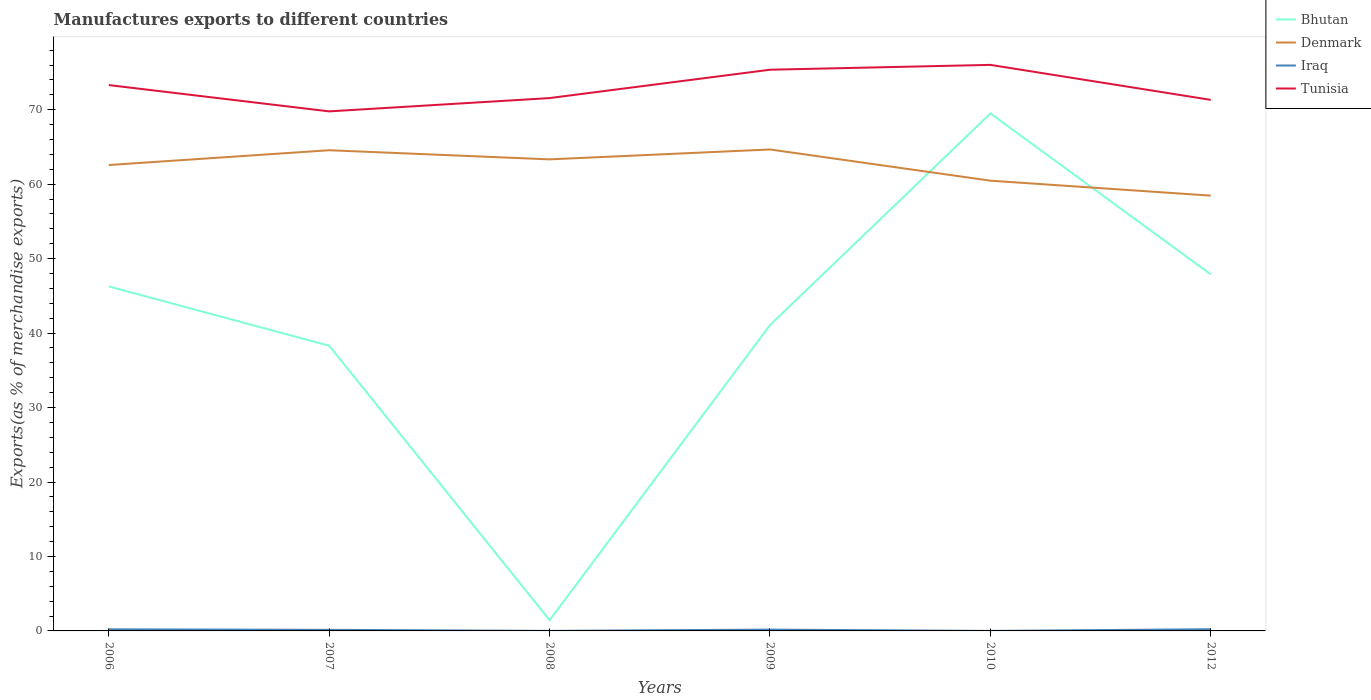How many different coloured lines are there?
Your response must be concise. 4. Across all years, what is the maximum percentage of exports to different countries in Iraq?
Your response must be concise. 1.17829425894477e-5. In which year was the percentage of exports to different countries in Tunisia maximum?
Provide a succinct answer. 2007. What is the total percentage of exports to different countries in Bhutan in the graph?
Provide a short and direct response. 5.19. What is the difference between the highest and the second highest percentage of exports to different countries in Bhutan?
Give a very brief answer. 68.06. Is the percentage of exports to different countries in Tunisia strictly greater than the percentage of exports to different countries in Iraq over the years?
Keep it short and to the point. No. How many lines are there?
Provide a short and direct response. 4. How many years are there in the graph?
Offer a terse response. 6. What is the difference between two consecutive major ticks on the Y-axis?
Your answer should be compact. 10. Are the values on the major ticks of Y-axis written in scientific E-notation?
Your answer should be compact. No. Does the graph contain any zero values?
Your response must be concise. No. Where does the legend appear in the graph?
Provide a short and direct response. Top right. How many legend labels are there?
Keep it short and to the point. 4. How are the legend labels stacked?
Your answer should be very brief. Vertical. What is the title of the graph?
Keep it short and to the point. Manufactures exports to different countries. What is the label or title of the Y-axis?
Offer a very short reply. Exports(as % of merchandise exports). What is the Exports(as % of merchandise exports) of Bhutan in 2006?
Your answer should be very brief. 46.27. What is the Exports(as % of merchandise exports) in Denmark in 2006?
Offer a terse response. 62.58. What is the Exports(as % of merchandise exports) of Iraq in 2006?
Make the answer very short. 0.22. What is the Exports(as % of merchandise exports) in Tunisia in 2006?
Your answer should be very brief. 73.31. What is the Exports(as % of merchandise exports) of Bhutan in 2007?
Your answer should be very brief. 38.3. What is the Exports(as % of merchandise exports) of Denmark in 2007?
Your response must be concise. 64.56. What is the Exports(as % of merchandise exports) of Iraq in 2007?
Keep it short and to the point. 0.14. What is the Exports(as % of merchandise exports) in Tunisia in 2007?
Your answer should be compact. 69.78. What is the Exports(as % of merchandise exports) in Bhutan in 2008?
Provide a short and direct response. 1.44. What is the Exports(as % of merchandise exports) of Denmark in 2008?
Offer a terse response. 63.34. What is the Exports(as % of merchandise exports) of Iraq in 2008?
Your answer should be compact. 0.01. What is the Exports(as % of merchandise exports) in Tunisia in 2008?
Make the answer very short. 71.57. What is the Exports(as % of merchandise exports) of Bhutan in 2009?
Offer a very short reply. 41.08. What is the Exports(as % of merchandise exports) of Denmark in 2009?
Give a very brief answer. 64.66. What is the Exports(as % of merchandise exports) in Iraq in 2009?
Provide a short and direct response. 0.18. What is the Exports(as % of merchandise exports) in Tunisia in 2009?
Make the answer very short. 75.37. What is the Exports(as % of merchandise exports) in Bhutan in 2010?
Offer a very short reply. 69.5. What is the Exports(as % of merchandise exports) in Denmark in 2010?
Make the answer very short. 60.47. What is the Exports(as % of merchandise exports) of Iraq in 2010?
Give a very brief answer. 1.17829425894477e-5. What is the Exports(as % of merchandise exports) in Tunisia in 2010?
Your response must be concise. 76.03. What is the Exports(as % of merchandise exports) in Bhutan in 2012?
Ensure brevity in your answer.  47.88. What is the Exports(as % of merchandise exports) of Denmark in 2012?
Your answer should be very brief. 58.46. What is the Exports(as % of merchandise exports) of Iraq in 2012?
Your answer should be compact. 0.23. What is the Exports(as % of merchandise exports) in Tunisia in 2012?
Offer a terse response. 71.32. Across all years, what is the maximum Exports(as % of merchandise exports) of Bhutan?
Make the answer very short. 69.5. Across all years, what is the maximum Exports(as % of merchandise exports) of Denmark?
Your answer should be compact. 64.66. Across all years, what is the maximum Exports(as % of merchandise exports) of Iraq?
Your response must be concise. 0.23. Across all years, what is the maximum Exports(as % of merchandise exports) in Tunisia?
Provide a short and direct response. 76.03. Across all years, what is the minimum Exports(as % of merchandise exports) of Bhutan?
Your response must be concise. 1.44. Across all years, what is the minimum Exports(as % of merchandise exports) of Denmark?
Offer a terse response. 58.46. Across all years, what is the minimum Exports(as % of merchandise exports) of Iraq?
Your answer should be very brief. 1.17829425894477e-5. Across all years, what is the minimum Exports(as % of merchandise exports) of Tunisia?
Your answer should be very brief. 69.78. What is the total Exports(as % of merchandise exports) of Bhutan in the graph?
Offer a very short reply. 244.47. What is the total Exports(as % of merchandise exports) in Denmark in the graph?
Your answer should be compact. 374.07. What is the total Exports(as % of merchandise exports) of Iraq in the graph?
Ensure brevity in your answer.  0.77. What is the total Exports(as % of merchandise exports) of Tunisia in the graph?
Your response must be concise. 437.38. What is the difference between the Exports(as % of merchandise exports) in Bhutan in 2006 and that in 2007?
Your response must be concise. 7.96. What is the difference between the Exports(as % of merchandise exports) of Denmark in 2006 and that in 2007?
Offer a very short reply. -1.99. What is the difference between the Exports(as % of merchandise exports) in Iraq in 2006 and that in 2007?
Make the answer very short. 0.07. What is the difference between the Exports(as % of merchandise exports) of Tunisia in 2006 and that in 2007?
Make the answer very short. 3.53. What is the difference between the Exports(as % of merchandise exports) in Bhutan in 2006 and that in 2008?
Your response must be concise. 44.83. What is the difference between the Exports(as % of merchandise exports) in Denmark in 2006 and that in 2008?
Offer a terse response. -0.76. What is the difference between the Exports(as % of merchandise exports) in Iraq in 2006 and that in 2008?
Give a very brief answer. 0.21. What is the difference between the Exports(as % of merchandise exports) of Tunisia in 2006 and that in 2008?
Make the answer very short. 1.75. What is the difference between the Exports(as % of merchandise exports) in Bhutan in 2006 and that in 2009?
Provide a short and direct response. 5.19. What is the difference between the Exports(as % of merchandise exports) of Denmark in 2006 and that in 2009?
Offer a terse response. -2.09. What is the difference between the Exports(as % of merchandise exports) in Iraq in 2006 and that in 2009?
Offer a very short reply. 0.04. What is the difference between the Exports(as % of merchandise exports) of Tunisia in 2006 and that in 2009?
Provide a short and direct response. -2.06. What is the difference between the Exports(as % of merchandise exports) of Bhutan in 2006 and that in 2010?
Make the answer very short. -23.24. What is the difference between the Exports(as % of merchandise exports) in Denmark in 2006 and that in 2010?
Provide a short and direct response. 2.1. What is the difference between the Exports(as % of merchandise exports) of Iraq in 2006 and that in 2010?
Offer a terse response. 0.22. What is the difference between the Exports(as % of merchandise exports) of Tunisia in 2006 and that in 2010?
Your answer should be compact. -2.71. What is the difference between the Exports(as % of merchandise exports) of Bhutan in 2006 and that in 2012?
Ensure brevity in your answer.  -1.61. What is the difference between the Exports(as % of merchandise exports) of Denmark in 2006 and that in 2012?
Ensure brevity in your answer.  4.11. What is the difference between the Exports(as % of merchandise exports) of Iraq in 2006 and that in 2012?
Offer a very short reply. -0.01. What is the difference between the Exports(as % of merchandise exports) in Tunisia in 2006 and that in 2012?
Provide a short and direct response. 1.99. What is the difference between the Exports(as % of merchandise exports) of Bhutan in 2007 and that in 2008?
Your answer should be compact. 36.86. What is the difference between the Exports(as % of merchandise exports) of Denmark in 2007 and that in 2008?
Give a very brief answer. 1.23. What is the difference between the Exports(as % of merchandise exports) of Iraq in 2007 and that in 2008?
Ensure brevity in your answer.  0.14. What is the difference between the Exports(as % of merchandise exports) in Tunisia in 2007 and that in 2008?
Give a very brief answer. -1.79. What is the difference between the Exports(as % of merchandise exports) in Bhutan in 2007 and that in 2009?
Provide a short and direct response. -2.77. What is the difference between the Exports(as % of merchandise exports) of Denmark in 2007 and that in 2009?
Offer a terse response. -0.1. What is the difference between the Exports(as % of merchandise exports) of Iraq in 2007 and that in 2009?
Keep it short and to the point. -0.03. What is the difference between the Exports(as % of merchandise exports) in Tunisia in 2007 and that in 2009?
Ensure brevity in your answer.  -5.59. What is the difference between the Exports(as % of merchandise exports) in Bhutan in 2007 and that in 2010?
Your answer should be compact. -31.2. What is the difference between the Exports(as % of merchandise exports) of Denmark in 2007 and that in 2010?
Your response must be concise. 4.09. What is the difference between the Exports(as % of merchandise exports) of Iraq in 2007 and that in 2010?
Your response must be concise. 0.14. What is the difference between the Exports(as % of merchandise exports) in Tunisia in 2007 and that in 2010?
Provide a succinct answer. -6.25. What is the difference between the Exports(as % of merchandise exports) in Bhutan in 2007 and that in 2012?
Make the answer very short. -9.57. What is the difference between the Exports(as % of merchandise exports) of Denmark in 2007 and that in 2012?
Your answer should be very brief. 6.1. What is the difference between the Exports(as % of merchandise exports) of Iraq in 2007 and that in 2012?
Your answer should be compact. -0.08. What is the difference between the Exports(as % of merchandise exports) of Tunisia in 2007 and that in 2012?
Make the answer very short. -1.54. What is the difference between the Exports(as % of merchandise exports) of Bhutan in 2008 and that in 2009?
Provide a short and direct response. -39.64. What is the difference between the Exports(as % of merchandise exports) in Denmark in 2008 and that in 2009?
Give a very brief answer. -1.33. What is the difference between the Exports(as % of merchandise exports) of Iraq in 2008 and that in 2009?
Offer a very short reply. -0.17. What is the difference between the Exports(as % of merchandise exports) in Tunisia in 2008 and that in 2009?
Ensure brevity in your answer.  -3.81. What is the difference between the Exports(as % of merchandise exports) in Bhutan in 2008 and that in 2010?
Provide a succinct answer. -68.06. What is the difference between the Exports(as % of merchandise exports) in Denmark in 2008 and that in 2010?
Keep it short and to the point. 2.86. What is the difference between the Exports(as % of merchandise exports) of Iraq in 2008 and that in 2010?
Provide a short and direct response. 0.01. What is the difference between the Exports(as % of merchandise exports) of Tunisia in 2008 and that in 2010?
Your answer should be very brief. -4.46. What is the difference between the Exports(as % of merchandise exports) of Bhutan in 2008 and that in 2012?
Provide a succinct answer. -46.44. What is the difference between the Exports(as % of merchandise exports) in Denmark in 2008 and that in 2012?
Make the answer very short. 4.87. What is the difference between the Exports(as % of merchandise exports) in Iraq in 2008 and that in 2012?
Make the answer very short. -0.22. What is the difference between the Exports(as % of merchandise exports) of Tunisia in 2008 and that in 2012?
Offer a very short reply. 0.24. What is the difference between the Exports(as % of merchandise exports) in Bhutan in 2009 and that in 2010?
Provide a succinct answer. -28.43. What is the difference between the Exports(as % of merchandise exports) of Denmark in 2009 and that in 2010?
Offer a very short reply. 4.19. What is the difference between the Exports(as % of merchandise exports) in Iraq in 2009 and that in 2010?
Ensure brevity in your answer.  0.18. What is the difference between the Exports(as % of merchandise exports) of Tunisia in 2009 and that in 2010?
Provide a succinct answer. -0.65. What is the difference between the Exports(as % of merchandise exports) in Bhutan in 2009 and that in 2012?
Provide a short and direct response. -6.8. What is the difference between the Exports(as % of merchandise exports) of Denmark in 2009 and that in 2012?
Provide a short and direct response. 6.2. What is the difference between the Exports(as % of merchandise exports) of Iraq in 2009 and that in 2012?
Your answer should be very brief. -0.05. What is the difference between the Exports(as % of merchandise exports) in Tunisia in 2009 and that in 2012?
Your response must be concise. 4.05. What is the difference between the Exports(as % of merchandise exports) of Bhutan in 2010 and that in 2012?
Offer a very short reply. 21.63. What is the difference between the Exports(as % of merchandise exports) of Denmark in 2010 and that in 2012?
Give a very brief answer. 2.01. What is the difference between the Exports(as % of merchandise exports) in Iraq in 2010 and that in 2012?
Your response must be concise. -0.23. What is the difference between the Exports(as % of merchandise exports) of Tunisia in 2010 and that in 2012?
Your answer should be very brief. 4.7. What is the difference between the Exports(as % of merchandise exports) in Bhutan in 2006 and the Exports(as % of merchandise exports) in Denmark in 2007?
Provide a short and direct response. -18.29. What is the difference between the Exports(as % of merchandise exports) in Bhutan in 2006 and the Exports(as % of merchandise exports) in Iraq in 2007?
Your answer should be very brief. 46.12. What is the difference between the Exports(as % of merchandise exports) of Bhutan in 2006 and the Exports(as % of merchandise exports) of Tunisia in 2007?
Your answer should be very brief. -23.51. What is the difference between the Exports(as % of merchandise exports) of Denmark in 2006 and the Exports(as % of merchandise exports) of Iraq in 2007?
Keep it short and to the point. 62.43. What is the difference between the Exports(as % of merchandise exports) in Denmark in 2006 and the Exports(as % of merchandise exports) in Tunisia in 2007?
Offer a very short reply. -7.2. What is the difference between the Exports(as % of merchandise exports) of Iraq in 2006 and the Exports(as % of merchandise exports) of Tunisia in 2007?
Your answer should be very brief. -69.56. What is the difference between the Exports(as % of merchandise exports) of Bhutan in 2006 and the Exports(as % of merchandise exports) of Denmark in 2008?
Offer a very short reply. -17.07. What is the difference between the Exports(as % of merchandise exports) in Bhutan in 2006 and the Exports(as % of merchandise exports) in Iraq in 2008?
Your answer should be compact. 46.26. What is the difference between the Exports(as % of merchandise exports) of Bhutan in 2006 and the Exports(as % of merchandise exports) of Tunisia in 2008?
Provide a succinct answer. -25.3. What is the difference between the Exports(as % of merchandise exports) in Denmark in 2006 and the Exports(as % of merchandise exports) in Iraq in 2008?
Your response must be concise. 62.57. What is the difference between the Exports(as % of merchandise exports) in Denmark in 2006 and the Exports(as % of merchandise exports) in Tunisia in 2008?
Your response must be concise. -8.99. What is the difference between the Exports(as % of merchandise exports) in Iraq in 2006 and the Exports(as % of merchandise exports) in Tunisia in 2008?
Make the answer very short. -71.35. What is the difference between the Exports(as % of merchandise exports) in Bhutan in 2006 and the Exports(as % of merchandise exports) in Denmark in 2009?
Your answer should be very brief. -18.4. What is the difference between the Exports(as % of merchandise exports) of Bhutan in 2006 and the Exports(as % of merchandise exports) of Iraq in 2009?
Keep it short and to the point. 46.09. What is the difference between the Exports(as % of merchandise exports) of Bhutan in 2006 and the Exports(as % of merchandise exports) of Tunisia in 2009?
Your answer should be compact. -29.11. What is the difference between the Exports(as % of merchandise exports) in Denmark in 2006 and the Exports(as % of merchandise exports) in Iraq in 2009?
Provide a succinct answer. 62.4. What is the difference between the Exports(as % of merchandise exports) of Denmark in 2006 and the Exports(as % of merchandise exports) of Tunisia in 2009?
Keep it short and to the point. -12.8. What is the difference between the Exports(as % of merchandise exports) in Iraq in 2006 and the Exports(as % of merchandise exports) in Tunisia in 2009?
Provide a succinct answer. -75.16. What is the difference between the Exports(as % of merchandise exports) of Bhutan in 2006 and the Exports(as % of merchandise exports) of Denmark in 2010?
Provide a succinct answer. -14.21. What is the difference between the Exports(as % of merchandise exports) of Bhutan in 2006 and the Exports(as % of merchandise exports) of Iraq in 2010?
Your answer should be compact. 46.27. What is the difference between the Exports(as % of merchandise exports) of Bhutan in 2006 and the Exports(as % of merchandise exports) of Tunisia in 2010?
Make the answer very short. -29.76. What is the difference between the Exports(as % of merchandise exports) in Denmark in 2006 and the Exports(as % of merchandise exports) in Iraq in 2010?
Your answer should be very brief. 62.58. What is the difference between the Exports(as % of merchandise exports) in Denmark in 2006 and the Exports(as % of merchandise exports) in Tunisia in 2010?
Your response must be concise. -13.45. What is the difference between the Exports(as % of merchandise exports) of Iraq in 2006 and the Exports(as % of merchandise exports) of Tunisia in 2010?
Your answer should be very brief. -75.81. What is the difference between the Exports(as % of merchandise exports) of Bhutan in 2006 and the Exports(as % of merchandise exports) of Denmark in 2012?
Give a very brief answer. -12.2. What is the difference between the Exports(as % of merchandise exports) in Bhutan in 2006 and the Exports(as % of merchandise exports) in Iraq in 2012?
Provide a succinct answer. 46.04. What is the difference between the Exports(as % of merchandise exports) in Bhutan in 2006 and the Exports(as % of merchandise exports) in Tunisia in 2012?
Offer a very short reply. -25.06. What is the difference between the Exports(as % of merchandise exports) in Denmark in 2006 and the Exports(as % of merchandise exports) in Iraq in 2012?
Your answer should be very brief. 62.35. What is the difference between the Exports(as % of merchandise exports) in Denmark in 2006 and the Exports(as % of merchandise exports) in Tunisia in 2012?
Give a very brief answer. -8.75. What is the difference between the Exports(as % of merchandise exports) of Iraq in 2006 and the Exports(as % of merchandise exports) of Tunisia in 2012?
Provide a short and direct response. -71.11. What is the difference between the Exports(as % of merchandise exports) in Bhutan in 2007 and the Exports(as % of merchandise exports) in Denmark in 2008?
Make the answer very short. -25.03. What is the difference between the Exports(as % of merchandise exports) in Bhutan in 2007 and the Exports(as % of merchandise exports) in Iraq in 2008?
Make the answer very short. 38.3. What is the difference between the Exports(as % of merchandise exports) in Bhutan in 2007 and the Exports(as % of merchandise exports) in Tunisia in 2008?
Ensure brevity in your answer.  -33.26. What is the difference between the Exports(as % of merchandise exports) in Denmark in 2007 and the Exports(as % of merchandise exports) in Iraq in 2008?
Make the answer very short. 64.56. What is the difference between the Exports(as % of merchandise exports) of Denmark in 2007 and the Exports(as % of merchandise exports) of Tunisia in 2008?
Give a very brief answer. -7. What is the difference between the Exports(as % of merchandise exports) in Iraq in 2007 and the Exports(as % of merchandise exports) in Tunisia in 2008?
Your response must be concise. -71.42. What is the difference between the Exports(as % of merchandise exports) of Bhutan in 2007 and the Exports(as % of merchandise exports) of Denmark in 2009?
Your response must be concise. -26.36. What is the difference between the Exports(as % of merchandise exports) in Bhutan in 2007 and the Exports(as % of merchandise exports) in Iraq in 2009?
Ensure brevity in your answer.  38.13. What is the difference between the Exports(as % of merchandise exports) in Bhutan in 2007 and the Exports(as % of merchandise exports) in Tunisia in 2009?
Make the answer very short. -37.07. What is the difference between the Exports(as % of merchandise exports) in Denmark in 2007 and the Exports(as % of merchandise exports) in Iraq in 2009?
Ensure brevity in your answer.  64.39. What is the difference between the Exports(as % of merchandise exports) of Denmark in 2007 and the Exports(as % of merchandise exports) of Tunisia in 2009?
Keep it short and to the point. -10.81. What is the difference between the Exports(as % of merchandise exports) of Iraq in 2007 and the Exports(as % of merchandise exports) of Tunisia in 2009?
Offer a terse response. -75.23. What is the difference between the Exports(as % of merchandise exports) of Bhutan in 2007 and the Exports(as % of merchandise exports) of Denmark in 2010?
Offer a very short reply. -22.17. What is the difference between the Exports(as % of merchandise exports) in Bhutan in 2007 and the Exports(as % of merchandise exports) in Iraq in 2010?
Ensure brevity in your answer.  38.3. What is the difference between the Exports(as % of merchandise exports) of Bhutan in 2007 and the Exports(as % of merchandise exports) of Tunisia in 2010?
Ensure brevity in your answer.  -37.72. What is the difference between the Exports(as % of merchandise exports) of Denmark in 2007 and the Exports(as % of merchandise exports) of Iraq in 2010?
Provide a succinct answer. 64.56. What is the difference between the Exports(as % of merchandise exports) in Denmark in 2007 and the Exports(as % of merchandise exports) in Tunisia in 2010?
Provide a succinct answer. -11.46. What is the difference between the Exports(as % of merchandise exports) in Iraq in 2007 and the Exports(as % of merchandise exports) in Tunisia in 2010?
Your answer should be compact. -75.88. What is the difference between the Exports(as % of merchandise exports) of Bhutan in 2007 and the Exports(as % of merchandise exports) of Denmark in 2012?
Provide a succinct answer. -20.16. What is the difference between the Exports(as % of merchandise exports) in Bhutan in 2007 and the Exports(as % of merchandise exports) in Iraq in 2012?
Give a very brief answer. 38.08. What is the difference between the Exports(as % of merchandise exports) of Bhutan in 2007 and the Exports(as % of merchandise exports) of Tunisia in 2012?
Your answer should be very brief. -33.02. What is the difference between the Exports(as % of merchandise exports) of Denmark in 2007 and the Exports(as % of merchandise exports) of Iraq in 2012?
Make the answer very short. 64.33. What is the difference between the Exports(as % of merchandise exports) in Denmark in 2007 and the Exports(as % of merchandise exports) in Tunisia in 2012?
Provide a succinct answer. -6.76. What is the difference between the Exports(as % of merchandise exports) in Iraq in 2007 and the Exports(as % of merchandise exports) in Tunisia in 2012?
Provide a succinct answer. -71.18. What is the difference between the Exports(as % of merchandise exports) of Bhutan in 2008 and the Exports(as % of merchandise exports) of Denmark in 2009?
Your answer should be compact. -63.22. What is the difference between the Exports(as % of merchandise exports) in Bhutan in 2008 and the Exports(as % of merchandise exports) in Iraq in 2009?
Offer a terse response. 1.26. What is the difference between the Exports(as % of merchandise exports) of Bhutan in 2008 and the Exports(as % of merchandise exports) of Tunisia in 2009?
Keep it short and to the point. -73.93. What is the difference between the Exports(as % of merchandise exports) in Denmark in 2008 and the Exports(as % of merchandise exports) in Iraq in 2009?
Your answer should be compact. 63.16. What is the difference between the Exports(as % of merchandise exports) in Denmark in 2008 and the Exports(as % of merchandise exports) in Tunisia in 2009?
Offer a very short reply. -12.04. What is the difference between the Exports(as % of merchandise exports) in Iraq in 2008 and the Exports(as % of merchandise exports) in Tunisia in 2009?
Ensure brevity in your answer.  -75.37. What is the difference between the Exports(as % of merchandise exports) of Bhutan in 2008 and the Exports(as % of merchandise exports) of Denmark in 2010?
Give a very brief answer. -59.03. What is the difference between the Exports(as % of merchandise exports) of Bhutan in 2008 and the Exports(as % of merchandise exports) of Iraq in 2010?
Keep it short and to the point. 1.44. What is the difference between the Exports(as % of merchandise exports) of Bhutan in 2008 and the Exports(as % of merchandise exports) of Tunisia in 2010?
Ensure brevity in your answer.  -74.58. What is the difference between the Exports(as % of merchandise exports) of Denmark in 2008 and the Exports(as % of merchandise exports) of Iraq in 2010?
Ensure brevity in your answer.  63.34. What is the difference between the Exports(as % of merchandise exports) in Denmark in 2008 and the Exports(as % of merchandise exports) in Tunisia in 2010?
Offer a terse response. -12.69. What is the difference between the Exports(as % of merchandise exports) in Iraq in 2008 and the Exports(as % of merchandise exports) in Tunisia in 2010?
Make the answer very short. -76.02. What is the difference between the Exports(as % of merchandise exports) of Bhutan in 2008 and the Exports(as % of merchandise exports) of Denmark in 2012?
Your answer should be very brief. -57.02. What is the difference between the Exports(as % of merchandise exports) in Bhutan in 2008 and the Exports(as % of merchandise exports) in Iraq in 2012?
Provide a succinct answer. 1.21. What is the difference between the Exports(as % of merchandise exports) in Bhutan in 2008 and the Exports(as % of merchandise exports) in Tunisia in 2012?
Provide a short and direct response. -69.88. What is the difference between the Exports(as % of merchandise exports) of Denmark in 2008 and the Exports(as % of merchandise exports) of Iraq in 2012?
Keep it short and to the point. 63.11. What is the difference between the Exports(as % of merchandise exports) of Denmark in 2008 and the Exports(as % of merchandise exports) of Tunisia in 2012?
Keep it short and to the point. -7.99. What is the difference between the Exports(as % of merchandise exports) in Iraq in 2008 and the Exports(as % of merchandise exports) in Tunisia in 2012?
Your answer should be compact. -71.32. What is the difference between the Exports(as % of merchandise exports) in Bhutan in 2009 and the Exports(as % of merchandise exports) in Denmark in 2010?
Provide a succinct answer. -19.39. What is the difference between the Exports(as % of merchandise exports) in Bhutan in 2009 and the Exports(as % of merchandise exports) in Iraq in 2010?
Offer a very short reply. 41.08. What is the difference between the Exports(as % of merchandise exports) in Bhutan in 2009 and the Exports(as % of merchandise exports) in Tunisia in 2010?
Give a very brief answer. -34.95. What is the difference between the Exports(as % of merchandise exports) of Denmark in 2009 and the Exports(as % of merchandise exports) of Iraq in 2010?
Ensure brevity in your answer.  64.66. What is the difference between the Exports(as % of merchandise exports) of Denmark in 2009 and the Exports(as % of merchandise exports) of Tunisia in 2010?
Your answer should be compact. -11.36. What is the difference between the Exports(as % of merchandise exports) in Iraq in 2009 and the Exports(as % of merchandise exports) in Tunisia in 2010?
Your response must be concise. -75.85. What is the difference between the Exports(as % of merchandise exports) of Bhutan in 2009 and the Exports(as % of merchandise exports) of Denmark in 2012?
Keep it short and to the point. -17.38. What is the difference between the Exports(as % of merchandise exports) in Bhutan in 2009 and the Exports(as % of merchandise exports) in Iraq in 2012?
Offer a very short reply. 40.85. What is the difference between the Exports(as % of merchandise exports) in Bhutan in 2009 and the Exports(as % of merchandise exports) in Tunisia in 2012?
Offer a terse response. -30.25. What is the difference between the Exports(as % of merchandise exports) in Denmark in 2009 and the Exports(as % of merchandise exports) in Iraq in 2012?
Ensure brevity in your answer.  64.44. What is the difference between the Exports(as % of merchandise exports) of Denmark in 2009 and the Exports(as % of merchandise exports) of Tunisia in 2012?
Provide a short and direct response. -6.66. What is the difference between the Exports(as % of merchandise exports) in Iraq in 2009 and the Exports(as % of merchandise exports) in Tunisia in 2012?
Your answer should be compact. -71.15. What is the difference between the Exports(as % of merchandise exports) of Bhutan in 2010 and the Exports(as % of merchandise exports) of Denmark in 2012?
Give a very brief answer. 11.04. What is the difference between the Exports(as % of merchandise exports) in Bhutan in 2010 and the Exports(as % of merchandise exports) in Iraq in 2012?
Give a very brief answer. 69.28. What is the difference between the Exports(as % of merchandise exports) of Bhutan in 2010 and the Exports(as % of merchandise exports) of Tunisia in 2012?
Your answer should be very brief. -1.82. What is the difference between the Exports(as % of merchandise exports) in Denmark in 2010 and the Exports(as % of merchandise exports) in Iraq in 2012?
Your answer should be compact. 60.24. What is the difference between the Exports(as % of merchandise exports) of Denmark in 2010 and the Exports(as % of merchandise exports) of Tunisia in 2012?
Provide a succinct answer. -10.85. What is the difference between the Exports(as % of merchandise exports) of Iraq in 2010 and the Exports(as % of merchandise exports) of Tunisia in 2012?
Provide a succinct answer. -71.32. What is the average Exports(as % of merchandise exports) of Bhutan per year?
Keep it short and to the point. 40.75. What is the average Exports(as % of merchandise exports) of Denmark per year?
Ensure brevity in your answer.  62.35. What is the average Exports(as % of merchandise exports) in Iraq per year?
Give a very brief answer. 0.13. What is the average Exports(as % of merchandise exports) of Tunisia per year?
Keep it short and to the point. 72.9. In the year 2006, what is the difference between the Exports(as % of merchandise exports) in Bhutan and Exports(as % of merchandise exports) in Denmark?
Your answer should be compact. -16.31. In the year 2006, what is the difference between the Exports(as % of merchandise exports) of Bhutan and Exports(as % of merchandise exports) of Iraq?
Provide a succinct answer. 46.05. In the year 2006, what is the difference between the Exports(as % of merchandise exports) in Bhutan and Exports(as % of merchandise exports) in Tunisia?
Your answer should be compact. -27.04. In the year 2006, what is the difference between the Exports(as % of merchandise exports) of Denmark and Exports(as % of merchandise exports) of Iraq?
Give a very brief answer. 62.36. In the year 2006, what is the difference between the Exports(as % of merchandise exports) in Denmark and Exports(as % of merchandise exports) in Tunisia?
Provide a short and direct response. -10.74. In the year 2006, what is the difference between the Exports(as % of merchandise exports) in Iraq and Exports(as % of merchandise exports) in Tunisia?
Your answer should be compact. -73.1. In the year 2007, what is the difference between the Exports(as % of merchandise exports) in Bhutan and Exports(as % of merchandise exports) in Denmark?
Ensure brevity in your answer.  -26.26. In the year 2007, what is the difference between the Exports(as % of merchandise exports) of Bhutan and Exports(as % of merchandise exports) of Iraq?
Give a very brief answer. 38.16. In the year 2007, what is the difference between the Exports(as % of merchandise exports) in Bhutan and Exports(as % of merchandise exports) in Tunisia?
Make the answer very short. -31.48. In the year 2007, what is the difference between the Exports(as % of merchandise exports) in Denmark and Exports(as % of merchandise exports) in Iraq?
Ensure brevity in your answer.  64.42. In the year 2007, what is the difference between the Exports(as % of merchandise exports) of Denmark and Exports(as % of merchandise exports) of Tunisia?
Provide a succinct answer. -5.22. In the year 2007, what is the difference between the Exports(as % of merchandise exports) of Iraq and Exports(as % of merchandise exports) of Tunisia?
Offer a very short reply. -69.64. In the year 2008, what is the difference between the Exports(as % of merchandise exports) in Bhutan and Exports(as % of merchandise exports) in Denmark?
Offer a very short reply. -61.89. In the year 2008, what is the difference between the Exports(as % of merchandise exports) of Bhutan and Exports(as % of merchandise exports) of Iraq?
Your answer should be very brief. 1.43. In the year 2008, what is the difference between the Exports(as % of merchandise exports) in Bhutan and Exports(as % of merchandise exports) in Tunisia?
Give a very brief answer. -70.13. In the year 2008, what is the difference between the Exports(as % of merchandise exports) in Denmark and Exports(as % of merchandise exports) in Iraq?
Your answer should be compact. 63.33. In the year 2008, what is the difference between the Exports(as % of merchandise exports) of Denmark and Exports(as % of merchandise exports) of Tunisia?
Your answer should be very brief. -8.23. In the year 2008, what is the difference between the Exports(as % of merchandise exports) of Iraq and Exports(as % of merchandise exports) of Tunisia?
Provide a short and direct response. -71.56. In the year 2009, what is the difference between the Exports(as % of merchandise exports) of Bhutan and Exports(as % of merchandise exports) of Denmark?
Provide a short and direct response. -23.59. In the year 2009, what is the difference between the Exports(as % of merchandise exports) in Bhutan and Exports(as % of merchandise exports) in Iraq?
Offer a terse response. 40.9. In the year 2009, what is the difference between the Exports(as % of merchandise exports) of Bhutan and Exports(as % of merchandise exports) of Tunisia?
Your answer should be compact. -34.3. In the year 2009, what is the difference between the Exports(as % of merchandise exports) in Denmark and Exports(as % of merchandise exports) in Iraq?
Provide a short and direct response. 64.49. In the year 2009, what is the difference between the Exports(as % of merchandise exports) in Denmark and Exports(as % of merchandise exports) in Tunisia?
Provide a succinct answer. -10.71. In the year 2009, what is the difference between the Exports(as % of merchandise exports) in Iraq and Exports(as % of merchandise exports) in Tunisia?
Your answer should be compact. -75.2. In the year 2010, what is the difference between the Exports(as % of merchandise exports) in Bhutan and Exports(as % of merchandise exports) in Denmark?
Your response must be concise. 9.03. In the year 2010, what is the difference between the Exports(as % of merchandise exports) in Bhutan and Exports(as % of merchandise exports) in Iraq?
Offer a very short reply. 69.5. In the year 2010, what is the difference between the Exports(as % of merchandise exports) in Bhutan and Exports(as % of merchandise exports) in Tunisia?
Keep it short and to the point. -6.52. In the year 2010, what is the difference between the Exports(as % of merchandise exports) of Denmark and Exports(as % of merchandise exports) of Iraq?
Provide a succinct answer. 60.47. In the year 2010, what is the difference between the Exports(as % of merchandise exports) of Denmark and Exports(as % of merchandise exports) of Tunisia?
Offer a terse response. -15.55. In the year 2010, what is the difference between the Exports(as % of merchandise exports) in Iraq and Exports(as % of merchandise exports) in Tunisia?
Ensure brevity in your answer.  -76.03. In the year 2012, what is the difference between the Exports(as % of merchandise exports) in Bhutan and Exports(as % of merchandise exports) in Denmark?
Your answer should be very brief. -10.58. In the year 2012, what is the difference between the Exports(as % of merchandise exports) of Bhutan and Exports(as % of merchandise exports) of Iraq?
Provide a succinct answer. 47.65. In the year 2012, what is the difference between the Exports(as % of merchandise exports) of Bhutan and Exports(as % of merchandise exports) of Tunisia?
Offer a very short reply. -23.45. In the year 2012, what is the difference between the Exports(as % of merchandise exports) in Denmark and Exports(as % of merchandise exports) in Iraq?
Make the answer very short. 58.23. In the year 2012, what is the difference between the Exports(as % of merchandise exports) in Denmark and Exports(as % of merchandise exports) in Tunisia?
Keep it short and to the point. -12.86. In the year 2012, what is the difference between the Exports(as % of merchandise exports) in Iraq and Exports(as % of merchandise exports) in Tunisia?
Your response must be concise. -71.1. What is the ratio of the Exports(as % of merchandise exports) of Bhutan in 2006 to that in 2007?
Your response must be concise. 1.21. What is the ratio of the Exports(as % of merchandise exports) in Denmark in 2006 to that in 2007?
Offer a very short reply. 0.97. What is the ratio of the Exports(as % of merchandise exports) of Iraq in 2006 to that in 2007?
Ensure brevity in your answer.  1.5. What is the ratio of the Exports(as % of merchandise exports) in Tunisia in 2006 to that in 2007?
Give a very brief answer. 1.05. What is the ratio of the Exports(as % of merchandise exports) of Bhutan in 2006 to that in 2008?
Offer a terse response. 32.1. What is the ratio of the Exports(as % of merchandise exports) of Iraq in 2006 to that in 2008?
Your answer should be compact. 34.74. What is the ratio of the Exports(as % of merchandise exports) of Tunisia in 2006 to that in 2008?
Provide a short and direct response. 1.02. What is the ratio of the Exports(as % of merchandise exports) in Bhutan in 2006 to that in 2009?
Your response must be concise. 1.13. What is the ratio of the Exports(as % of merchandise exports) in Denmark in 2006 to that in 2009?
Make the answer very short. 0.97. What is the ratio of the Exports(as % of merchandise exports) in Iraq in 2006 to that in 2009?
Your answer should be compact. 1.23. What is the ratio of the Exports(as % of merchandise exports) of Tunisia in 2006 to that in 2009?
Keep it short and to the point. 0.97. What is the ratio of the Exports(as % of merchandise exports) in Bhutan in 2006 to that in 2010?
Your answer should be very brief. 0.67. What is the ratio of the Exports(as % of merchandise exports) of Denmark in 2006 to that in 2010?
Your answer should be compact. 1.03. What is the ratio of the Exports(as % of merchandise exports) of Iraq in 2006 to that in 2010?
Provide a short and direct response. 1.84e+04. What is the ratio of the Exports(as % of merchandise exports) of Bhutan in 2006 to that in 2012?
Give a very brief answer. 0.97. What is the ratio of the Exports(as % of merchandise exports) of Denmark in 2006 to that in 2012?
Your answer should be very brief. 1.07. What is the ratio of the Exports(as % of merchandise exports) in Iraq in 2006 to that in 2012?
Your answer should be very brief. 0.95. What is the ratio of the Exports(as % of merchandise exports) of Tunisia in 2006 to that in 2012?
Your answer should be very brief. 1.03. What is the ratio of the Exports(as % of merchandise exports) of Bhutan in 2007 to that in 2008?
Make the answer very short. 26.58. What is the ratio of the Exports(as % of merchandise exports) of Denmark in 2007 to that in 2008?
Provide a succinct answer. 1.02. What is the ratio of the Exports(as % of merchandise exports) of Iraq in 2007 to that in 2008?
Offer a very short reply. 23.22. What is the ratio of the Exports(as % of merchandise exports) of Tunisia in 2007 to that in 2008?
Offer a very short reply. 0.97. What is the ratio of the Exports(as % of merchandise exports) in Bhutan in 2007 to that in 2009?
Offer a very short reply. 0.93. What is the ratio of the Exports(as % of merchandise exports) in Denmark in 2007 to that in 2009?
Make the answer very short. 1. What is the ratio of the Exports(as % of merchandise exports) in Iraq in 2007 to that in 2009?
Your response must be concise. 0.82. What is the ratio of the Exports(as % of merchandise exports) in Tunisia in 2007 to that in 2009?
Your answer should be very brief. 0.93. What is the ratio of the Exports(as % of merchandise exports) in Bhutan in 2007 to that in 2010?
Keep it short and to the point. 0.55. What is the ratio of the Exports(as % of merchandise exports) of Denmark in 2007 to that in 2010?
Give a very brief answer. 1.07. What is the ratio of the Exports(as % of merchandise exports) in Iraq in 2007 to that in 2010?
Offer a terse response. 1.23e+04. What is the ratio of the Exports(as % of merchandise exports) of Tunisia in 2007 to that in 2010?
Make the answer very short. 0.92. What is the ratio of the Exports(as % of merchandise exports) of Denmark in 2007 to that in 2012?
Give a very brief answer. 1.1. What is the ratio of the Exports(as % of merchandise exports) of Iraq in 2007 to that in 2012?
Your answer should be compact. 0.63. What is the ratio of the Exports(as % of merchandise exports) in Tunisia in 2007 to that in 2012?
Ensure brevity in your answer.  0.98. What is the ratio of the Exports(as % of merchandise exports) of Bhutan in 2008 to that in 2009?
Give a very brief answer. 0.04. What is the ratio of the Exports(as % of merchandise exports) of Denmark in 2008 to that in 2009?
Make the answer very short. 0.98. What is the ratio of the Exports(as % of merchandise exports) in Iraq in 2008 to that in 2009?
Provide a succinct answer. 0.04. What is the ratio of the Exports(as % of merchandise exports) in Tunisia in 2008 to that in 2009?
Ensure brevity in your answer.  0.95. What is the ratio of the Exports(as % of merchandise exports) in Bhutan in 2008 to that in 2010?
Give a very brief answer. 0.02. What is the ratio of the Exports(as % of merchandise exports) of Denmark in 2008 to that in 2010?
Ensure brevity in your answer.  1.05. What is the ratio of the Exports(as % of merchandise exports) in Iraq in 2008 to that in 2010?
Your response must be concise. 528.45. What is the ratio of the Exports(as % of merchandise exports) of Tunisia in 2008 to that in 2010?
Your response must be concise. 0.94. What is the ratio of the Exports(as % of merchandise exports) in Bhutan in 2008 to that in 2012?
Provide a succinct answer. 0.03. What is the ratio of the Exports(as % of merchandise exports) of Iraq in 2008 to that in 2012?
Make the answer very short. 0.03. What is the ratio of the Exports(as % of merchandise exports) in Bhutan in 2009 to that in 2010?
Keep it short and to the point. 0.59. What is the ratio of the Exports(as % of merchandise exports) in Denmark in 2009 to that in 2010?
Your answer should be compact. 1.07. What is the ratio of the Exports(as % of merchandise exports) in Iraq in 2009 to that in 2010?
Your answer should be very brief. 1.50e+04. What is the ratio of the Exports(as % of merchandise exports) of Bhutan in 2009 to that in 2012?
Offer a very short reply. 0.86. What is the ratio of the Exports(as % of merchandise exports) of Denmark in 2009 to that in 2012?
Offer a terse response. 1.11. What is the ratio of the Exports(as % of merchandise exports) in Iraq in 2009 to that in 2012?
Your answer should be very brief. 0.77. What is the ratio of the Exports(as % of merchandise exports) in Tunisia in 2009 to that in 2012?
Offer a very short reply. 1.06. What is the ratio of the Exports(as % of merchandise exports) of Bhutan in 2010 to that in 2012?
Give a very brief answer. 1.45. What is the ratio of the Exports(as % of merchandise exports) of Denmark in 2010 to that in 2012?
Your response must be concise. 1.03. What is the ratio of the Exports(as % of merchandise exports) in Tunisia in 2010 to that in 2012?
Offer a terse response. 1.07. What is the difference between the highest and the second highest Exports(as % of merchandise exports) in Bhutan?
Your response must be concise. 21.63. What is the difference between the highest and the second highest Exports(as % of merchandise exports) of Denmark?
Your answer should be compact. 0.1. What is the difference between the highest and the second highest Exports(as % of merchandise exports) of Iraq?
Provide a succinct answer. 0.01. What is the difference between the highest and the second highest Exports(as % of merchandise exports) of Tunisia?
Keep it short and to the point. 0.65. What is the difference between the highest and the lowest Exports(as % of merchandise exports) in Bhutan?
Offer a terse response. 68.06. What is the difference between the highest and the lowest Exports(as % of merchandise exports) in Denmark?
Give a very brief answer. 6.2. What is the difference between the highest and the lowest Exports(as % of merchandise exports) in Iraq?
Your answer should be compact. 0.23. What is the difference between the highest and the lowest Exports(as % of merchandise exports) of Tunisia?
Offer a terse response. 6.25. 